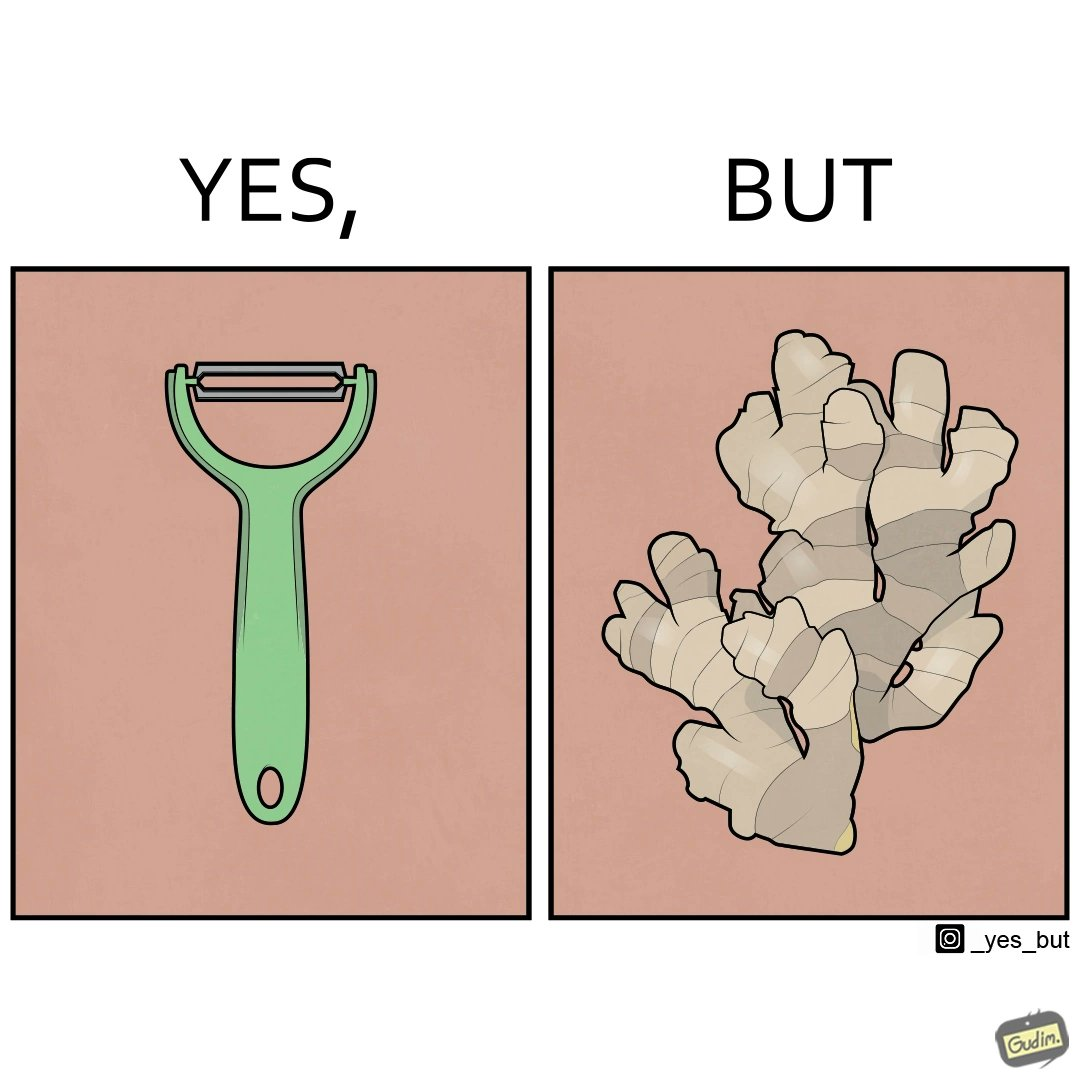What does this image depict? The image is funny because it suggests that while we have peelers to peel off the skin of many different fruits and vegetables, it is useless against a ginger which has a very complicated shape. 